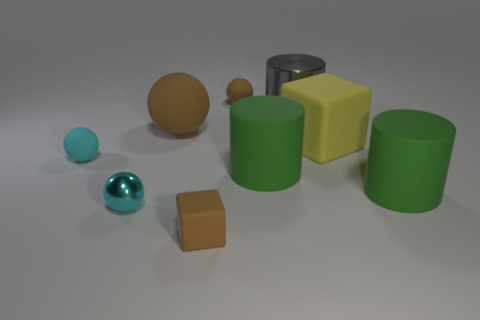How are the objects arranged in relation to each other? The objects are arranged in a scattered formation, with no apparent pattern. The two cyan spheres are closer to the foreground, with one being directly in front of the other. The yellow cube and one of the green cylinders are positioned near each other, and the brown cube and sphere are somewhat isolated from the rest. This random placement creates a sense of casualness as if the objects were arbitrarily placed within the scene. 